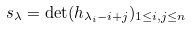<formula> <loc_0><loc_0><loc_500><loc_500>s _ { \lambda } = \det ( h _ { \lambda _ { i } - i + j } ) _ { 1 \leq i , j \leq n }</formula> 